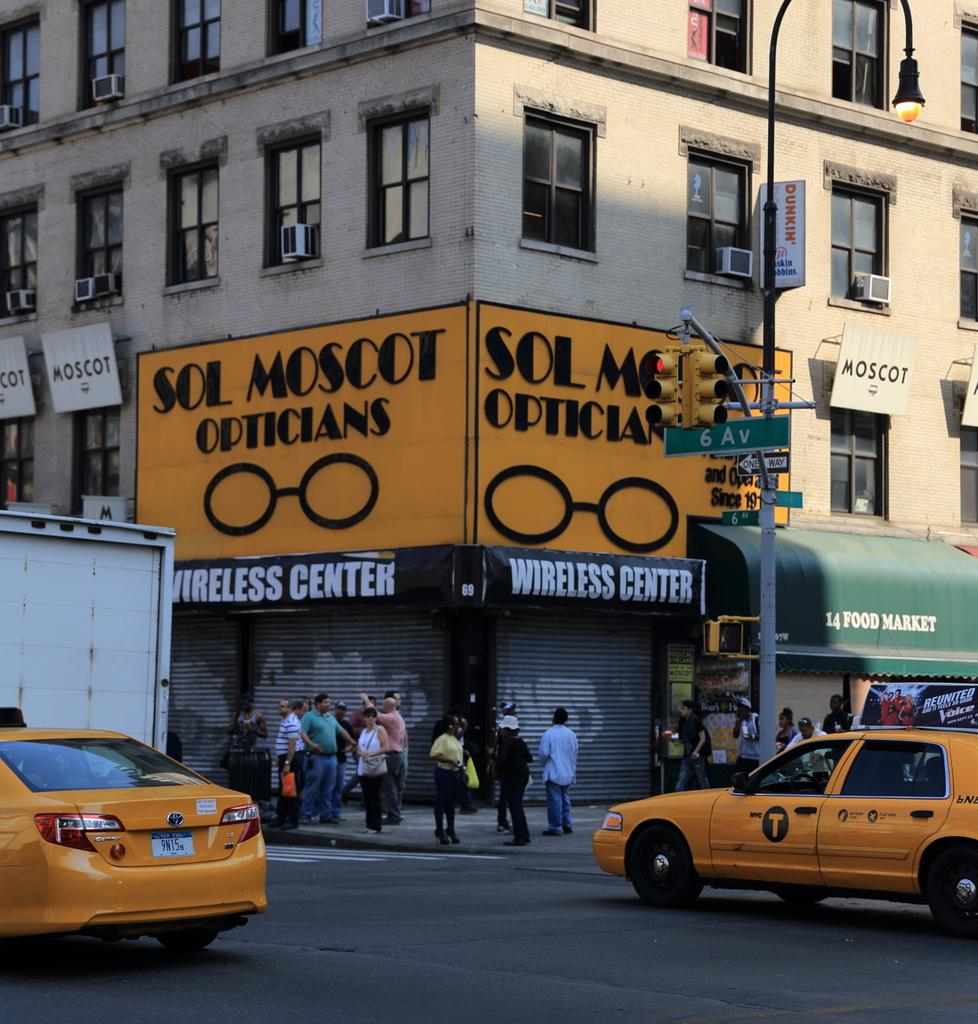Provide a one-sentence caption for the provided image. A corner store that is called Sol Moscot Opticians. 